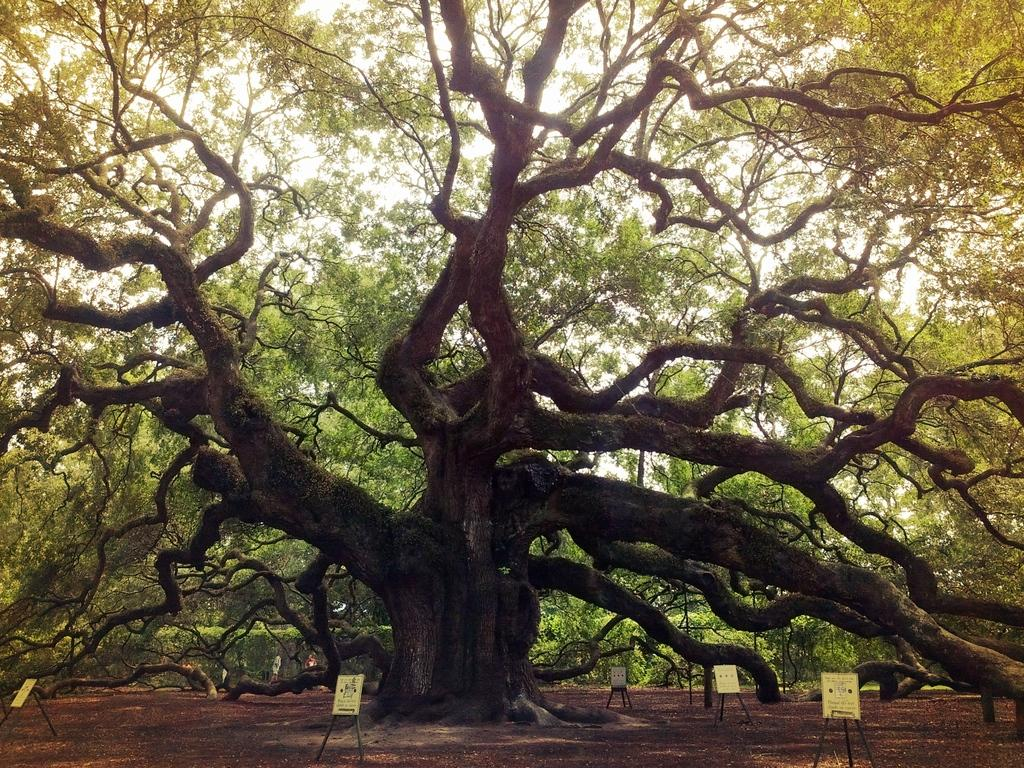What type of plant can be seen in the image? There is a tree in the image. What other objects are present in the image? There are wooden stand boards in the image. Where is the sister of the tree located in the image? There is no sister of the tree present in the image, as trees do not have siblings. What type of structure is the dock in the image? There is no dock present in the image; it only features a tree and wooden stand boards. 